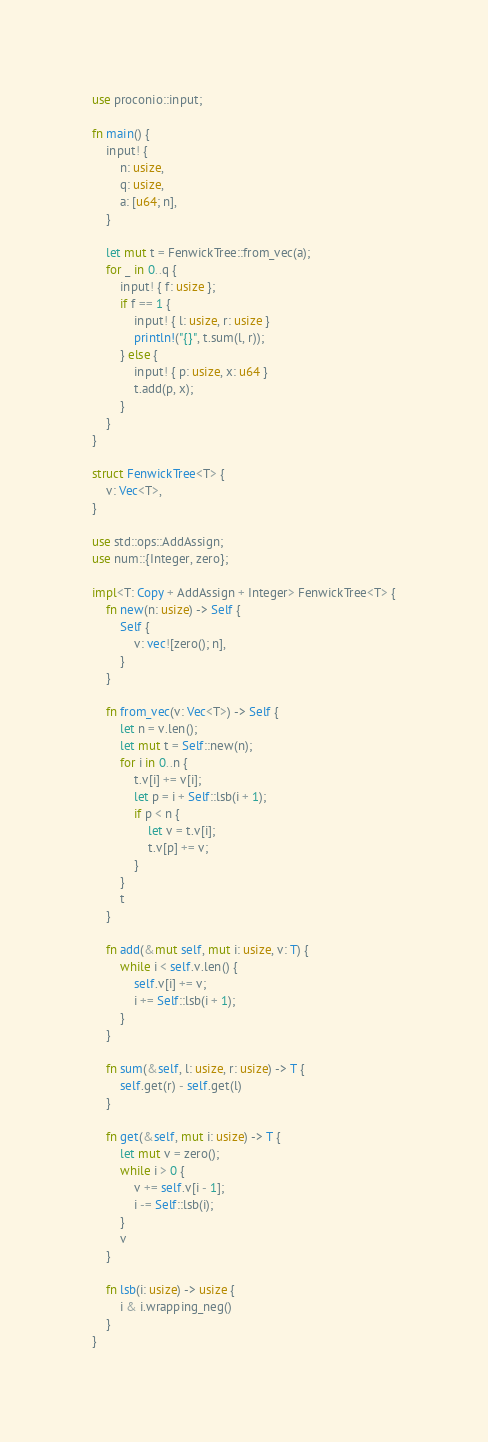<code> <loc_0><loc_0><loc_500><loc_500><_Rust_>use proconio::input;

fn main() {
    input! {
        n: usize,
        q: usize,
        a: [u64; n],
    }

    let mut t = FenwickTree::from_vec(a);
    for _ in 0..q {
        input! { f: usize };
        if f == 1 {
            input! { l: usize, r: usize }
            println!("{}", t.sum(l, r));
        } else {
            input! { p: usize, x: u64 }
            t.add(p, x);
        }
    }
}

struct FenwickTree<T> {
    v: Vec<T>,
}

use std::ops::AddAssign;
use num::{Integer, zero};

impl<T: Copy + AddAssign + Integer> FenwickTree<T> {
    fn new(n: usize) -> Self {
        Self {
            v: vec![zero(); n],
        }
    }

    fn from_vec(v: Vec<T>) -> Self {
        let n = v.len();
        let mut t = Self::new(n);
        for i in 0..n {
            t.v[i] += v[i];
            let p = i + Self::lsb(i + 1);
            if p < n {
                let v = t.v[i];
                t.v[p] += v;
            }
        }
        t
    }

    fn add(&mut self, mut i: usize, v: T) {
        while i < self.v.len() {
            self.v[i] += v;
            i += Self::lsb(i + 1);
        }
    }

    fn sum(&self, l: usize, r: usize) -> T {
        self.get(r) - self.get(l)
    }

    fn get(&self, mut i: usize) -> T {
        let mut v = zero();
        while i > 0 {
            v += self.v[i - 1];
            i -= Self::lsb(i);
        }
        v
    }

    fn lsb(i: usize) -> usize {
        i & i.wrapping_neg()
    }
}
</code> 